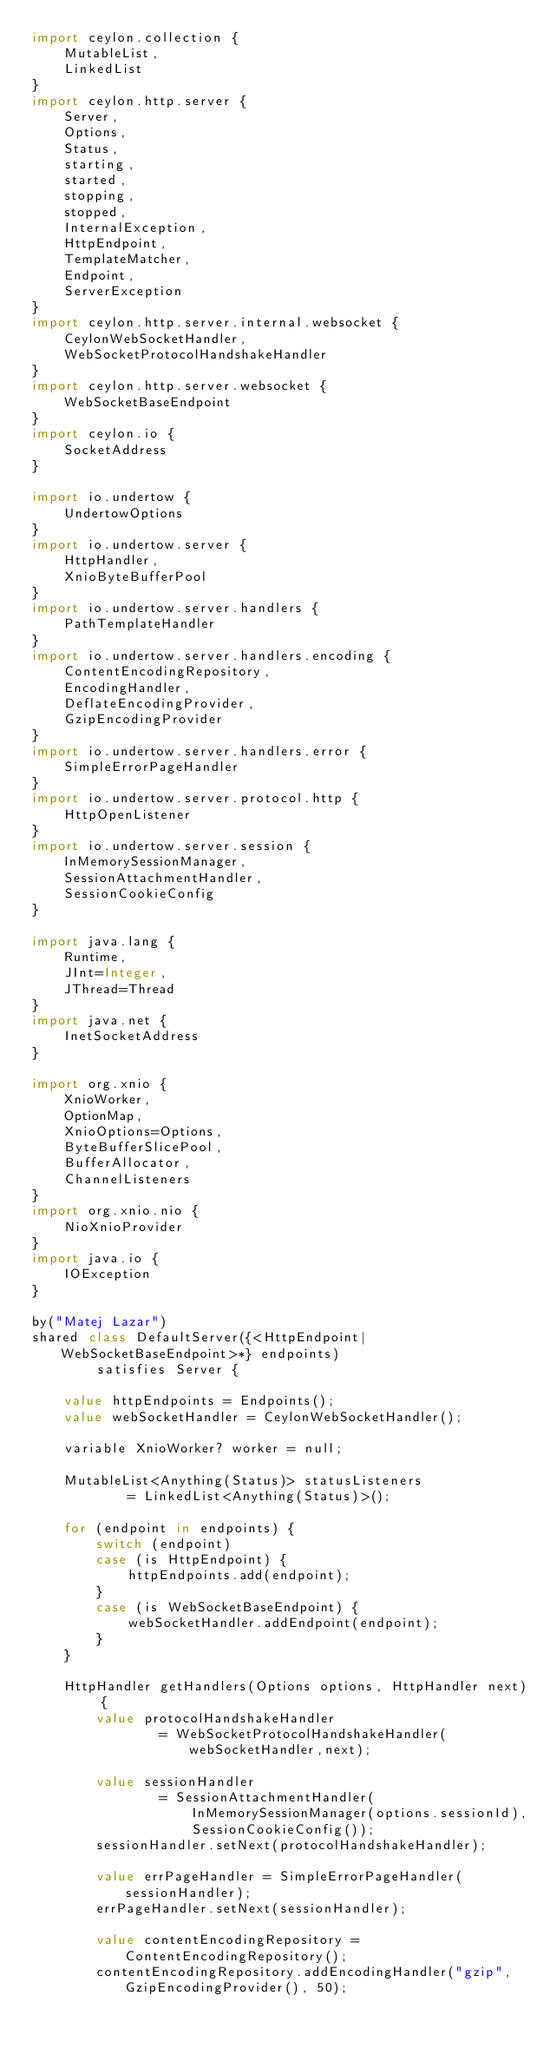Convert code to text. <code><loc_0><loc_0><loc_500><loc_500><_Ceylon_>import ceylon.collection {
    MutableList,
    LinkedList
}
import ceylon.http.server {
    Server,
    Options,
    Status,
    starting,
    started,
    stopping,
    stopped,
    InternalException,
    HttpEndpoint,
    TemplateMatcher,
    Endpoint,
    ServerException
}
import ceylon.http.server.internal.websocket {
    CeylonWebSocketHandler,
    WebSocketProtocolHandshakeHandler
}
import ceylon.http.server.websocket {
    WebSocketBaseEndpoint
}
import ceylon.io {
    SocketAddress
}

import io.undertow {
    UndertowOptions
}
import io.undertow.server {
    HttpHandler,
    XnioByteBufferPool
}
import io.undertow.server.handlers {
    PathTemplateHandler
}
import io.undertow.server.handlers.encoding {
    ContentEncodingRepository,
    EncodingHandler,
    DeflateEncodingProvider,
    GzipEncodingProvider
}
import io.undertow.server.handlers.error {
    SimpleErrorPageHandler
}
import io.undertow.server.protocol.http {
    HttpOpenListener
}
import io.undertow.server.session {
    InMemorySessionManager,
    SessionAttachmentHandler,
    SessionCookieConfig
}

import java.lang {
    Runtime,
    JInt=Integer,
    JThread=Thread
}
import java.net {
    InetSocketAddress
}

import org.xnio {
    XnioWorker,
    OptionMap,
    XnioOptions=Options,
    ByteBufferSlicePool,
    BufferAllocator,
    ChannelListeners
}
import org.xnio.nio {
    NioXnioProvider
}
import java.io {
    IOException
}

by("Matej Lazar")
shared class DefaultServer({<HttpEndpoint|WebSocketBaseEndpoint>*} endpoints)
        satisfies Server {

    value httpEndpoints = Endpoints();
    value webSocketHandler = CeylonWebSocketHandler();

    variable XnioWorker? worker = null;

    MutableList<Anything(Status)> statusListeners 
            = LinkedList<Anything(Status)>();

    for (endpoint in endpoints) {
        switch (endpoint)
        case (is HttpEndpoint) {
            httpEndpoints.add(endpoint);
        }
        case (is WebSocketBaseEndpoint) {
            webSocketHandler.addEndpoint(endpoint);
        }
    }

    HttpHandler getHandlers(Options options, HttpHandler next) {
        value protocolHandshakeHandler 
                = WebSocketProtocolHandshakeHandler(webSocketHandler,next);
        
        value sessionHandler 
                = SessionAttachmentHandler(
                    InMemorySessionManager(options.sessionId),
                    SessionCookieConfig());
        sessionHandler.setNext(protocolHandshakeHandler);
        
        value errPageHandler = SimpleErrorPageHandler(sessionHandler);
        errPageHandler.setNext(sessionHandler);

        value contentEncodingRepository = ContentEncodingRepository();
        contentEncodingRepository.addEncodingHandler("gzip", GzipEncodingProvider(), 50);</code> 